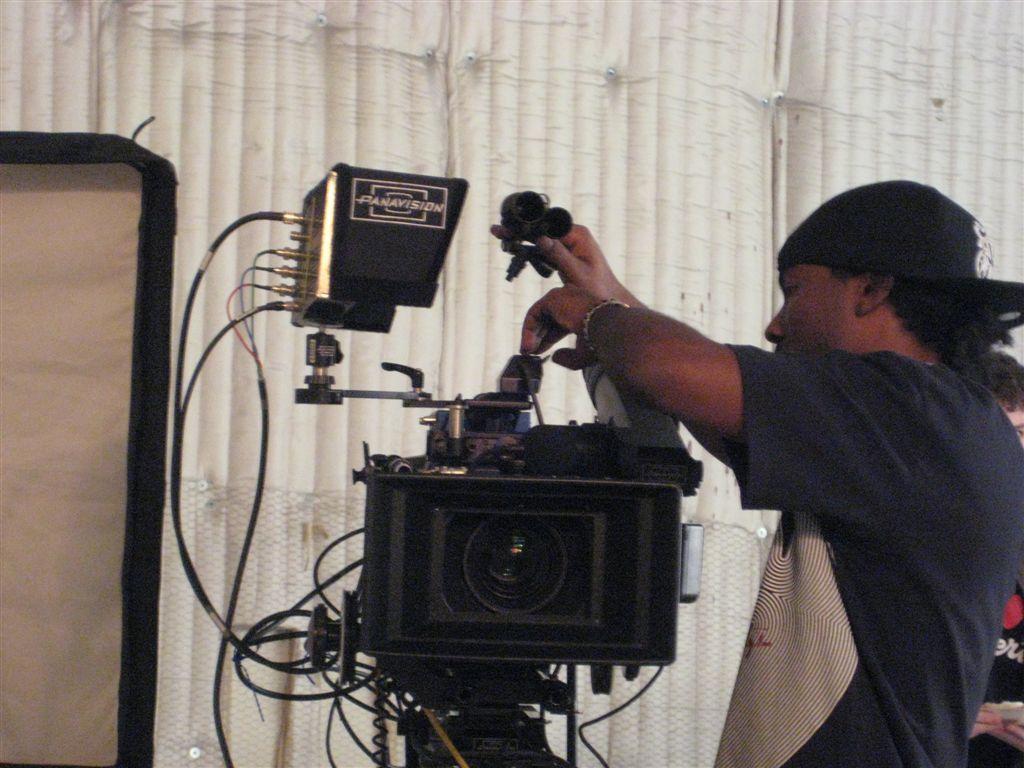In one or two sentences, can you explain what this image depicts? In this picture we can see a man wore a cap and holding a camera with his hands and in the background we can see a cloth, mesh and a person. 